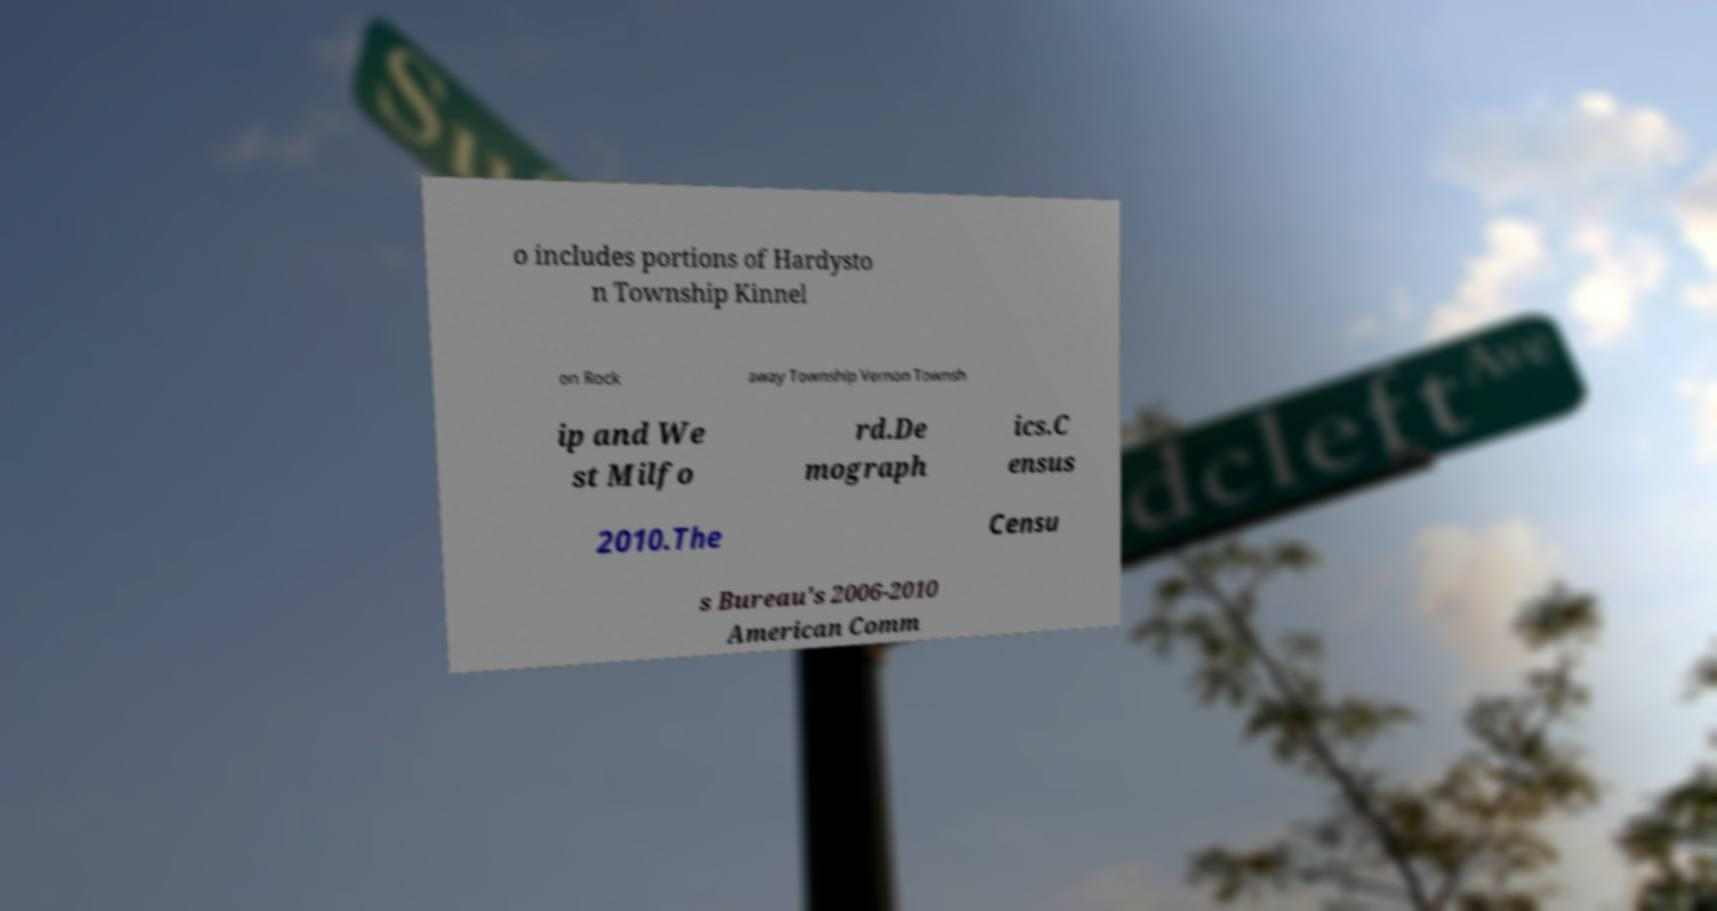For documentation purposes, I need the text within this image transcribed. Could you provide that? o includes portions of Hardysto n Township Kinnel on Rock away Township Vernon Townsh ip and We st Milfo rd.De mograph ics.C ensus 2010.The Censu s Bureau's 2006-2010 American Comm 